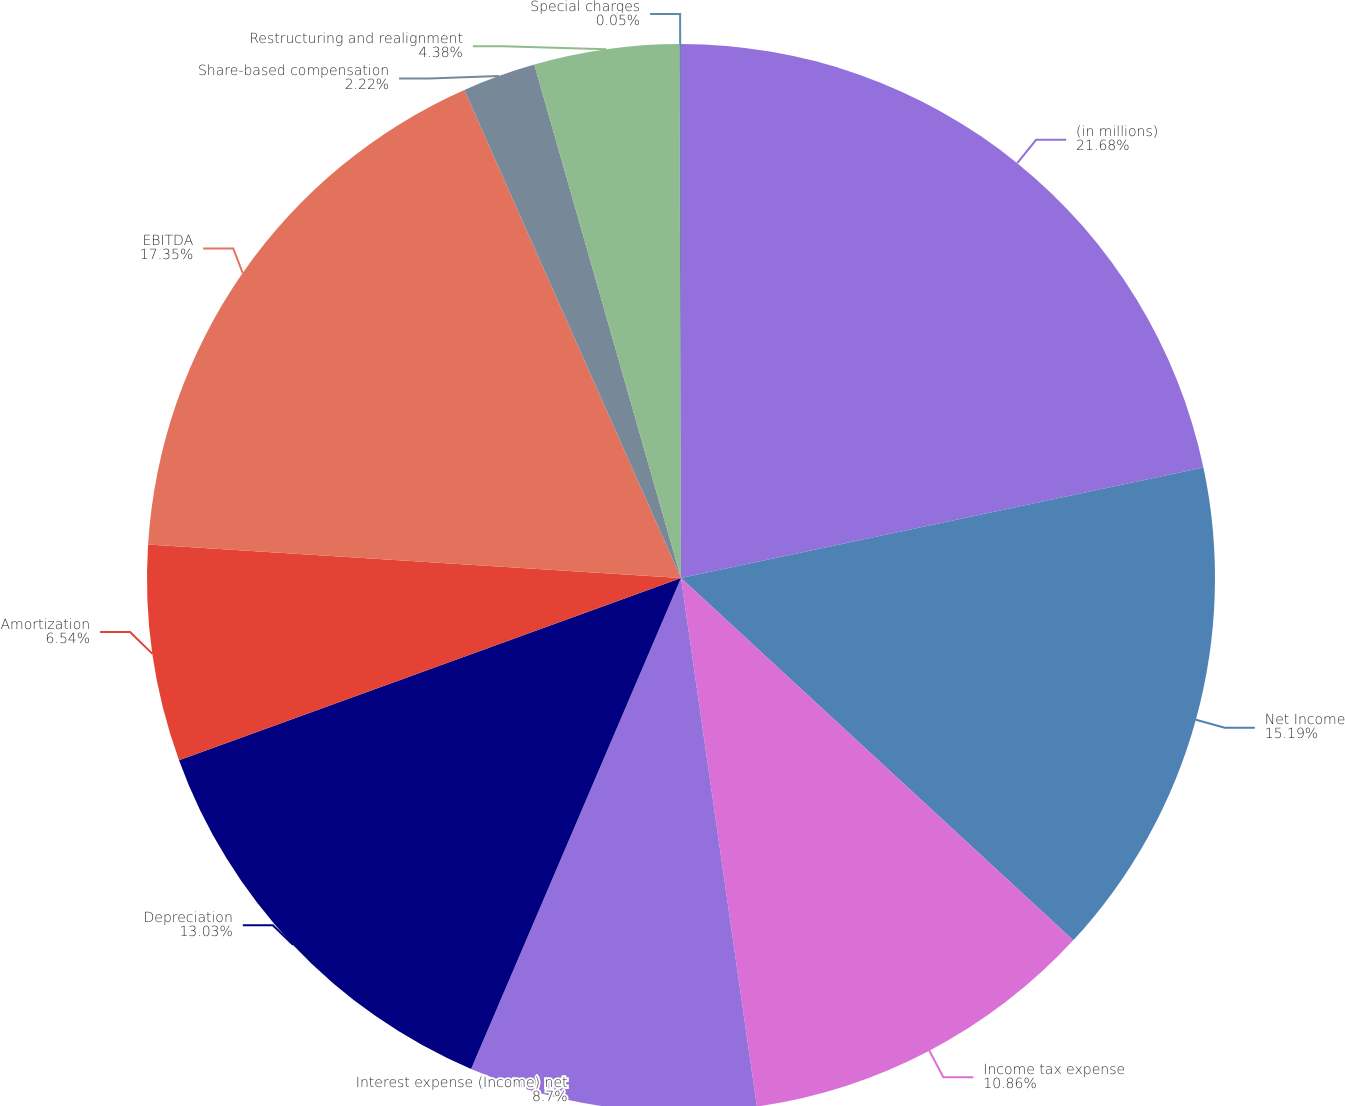Convert chart to OTSL. <chart><loc_0><loc_0><loc_500><loc_500><pie_chart><fcel>(in millions)<fcel>Net Income<fcel>Income tax expense<fcel>Interest expense (Income) net<fcel>Depreciation<fcel>Amortization<fcel>EBITDA<fcel>Share-based compensation<fcel>Restructuring and realignment<fcel>Special charges<nl><fcel>21.68%<fcel>15.19%<fcel>10.86%<fcel>8.7%<fcel>13.03%<fcel>6.54%<fcel>17.35%<fcel>2.22%<fcel>4.38%<fcel>0.05%<nl></chart> 